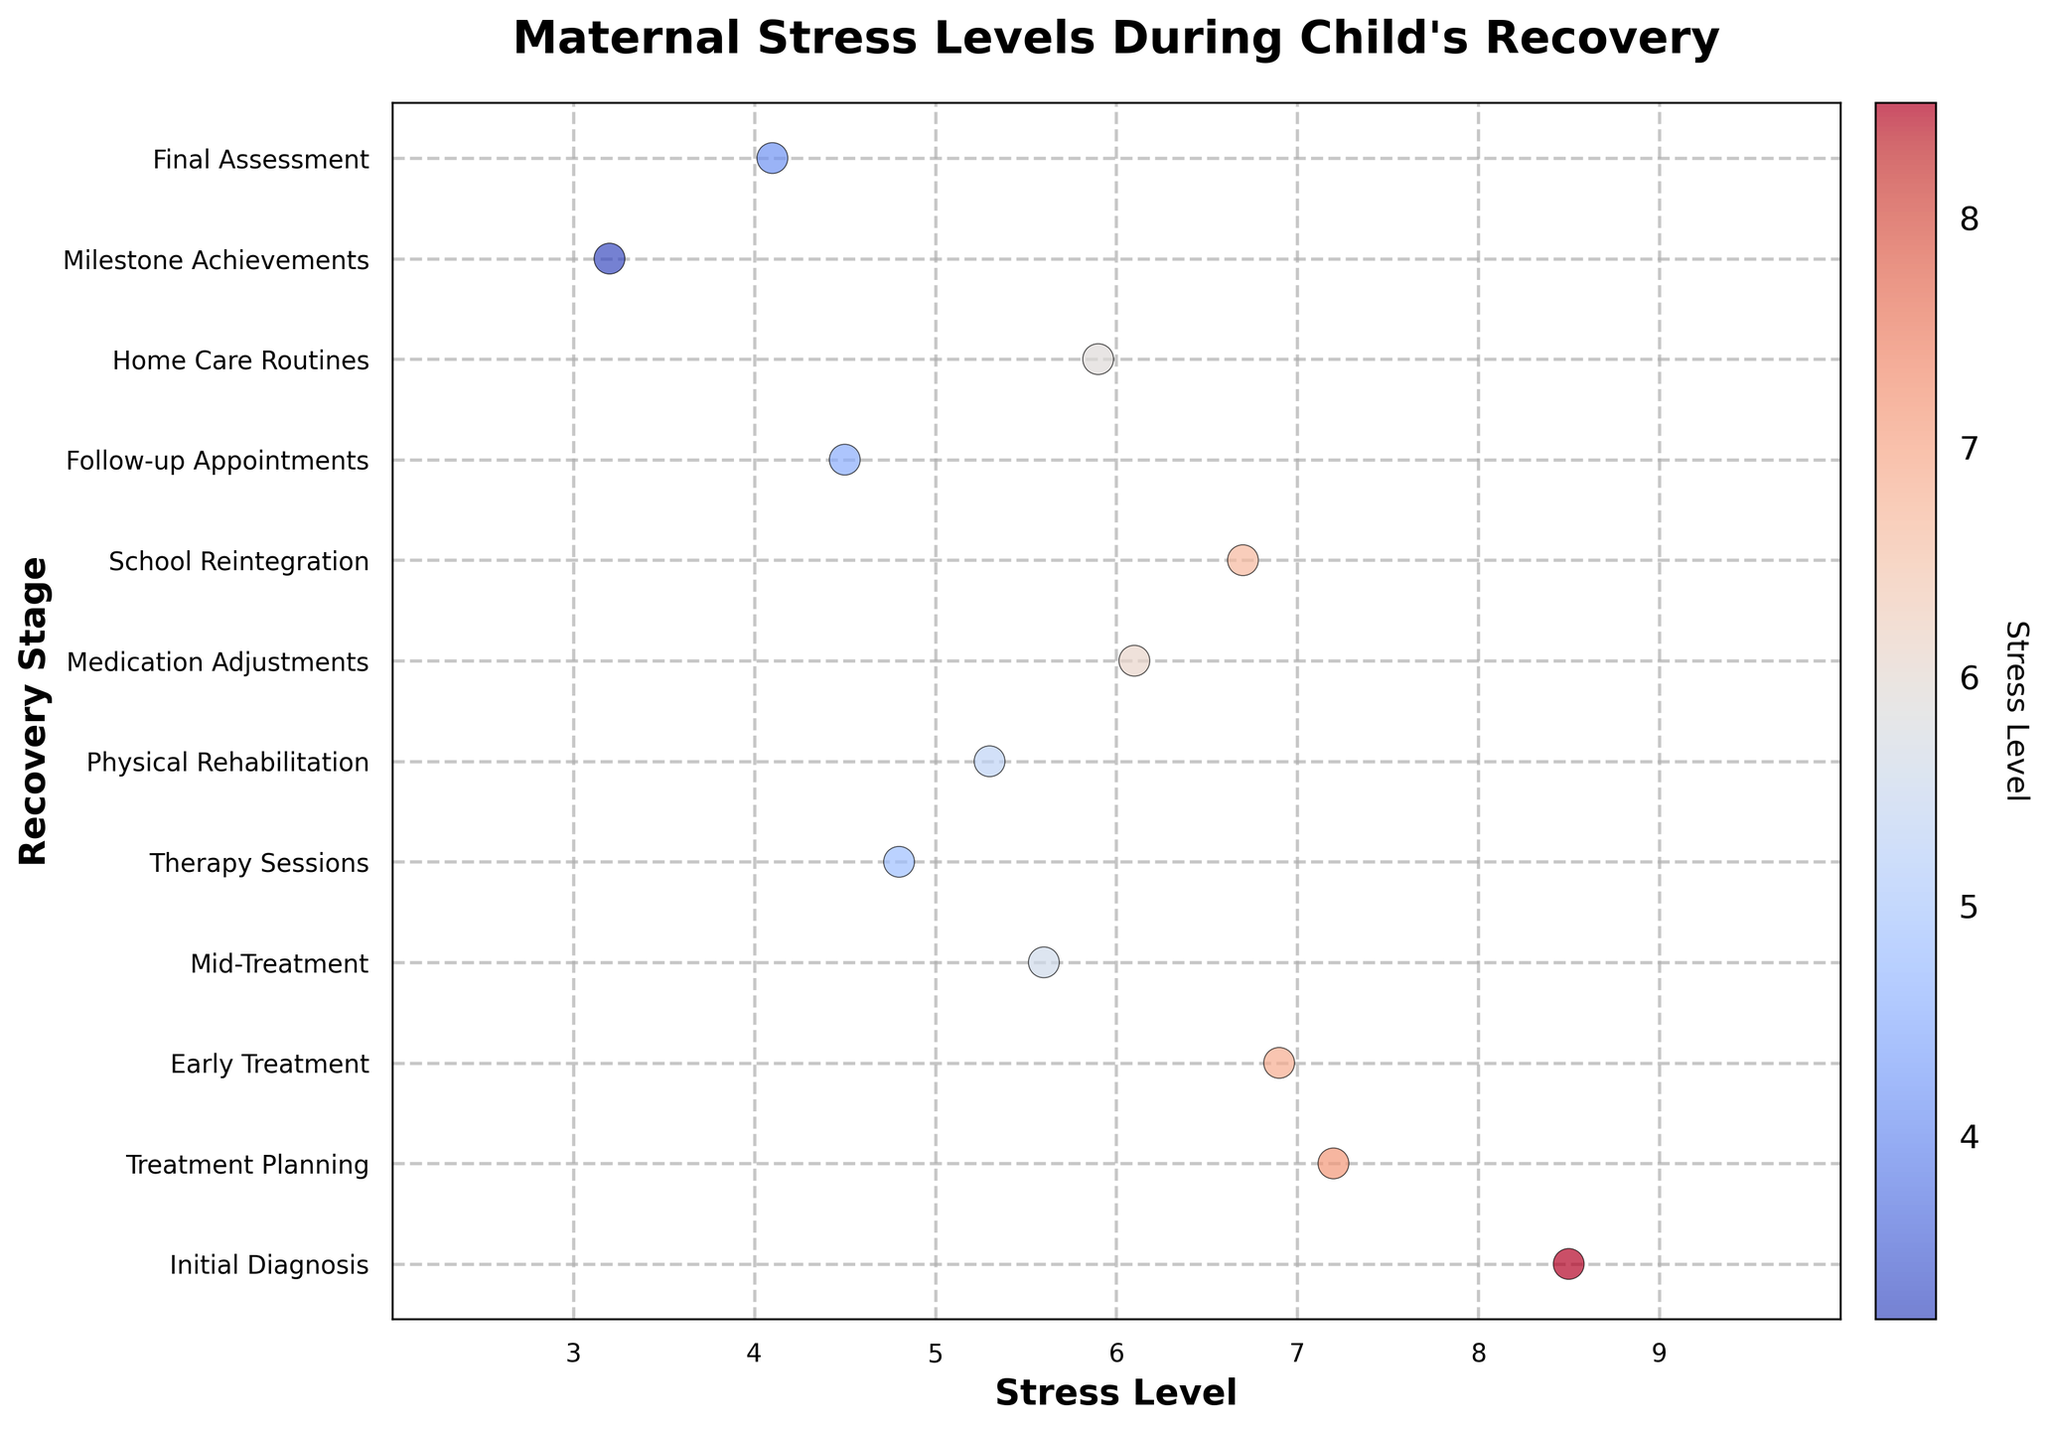What is the title of the plot? The title of the plot is displayed at the top. The text is bold and larger in size compared to the other text elements in the plot.
Answer: Maternal Stress Levels During Child's Recovery What is the stress level at the stage "Mid-Treatment"? Locate the point on the plot corresponding to "Mid-Treatment" on the y-axis, then trace horizontally to find the stress level value on the x-axis.
Answer: 5.6 Which recovery stage has the lowest stress level? Look for the point with the lowest value on the x-axis. Check the corresponding stage on the y-axis labels.
Answer: Milestone Achievements How many stages have stress levels above 6? Count the number of points located to the right of the stress level value of 6 on the x-axis.
Answer: 5 Compare the stress levels between "Initial Diagnosis" and "Final Assessment". Which stage has a higher stress level? Locate both "Initial Diagnosis" and "Final Assessment" on the y-axis, then compare their respective stress levels on the x-axis.
Answer: Initial Diagnosis What is the average stress level for the stages shown in the plot? Add all the stress levels together and divide by the number of stages (12). (8.5 + 7.2 + 6.9 + 5.6 + 4.8 + 5.3 + 6.1 + 6.7 + 4.5 + 5.9 + 3.2 + 4.1) / 12 ≈ 5.675
Answer: 5.675 Identify the color associated with the highest stress level. The color represents the stress level, and the highest stress level will correspond to the most intense shade on the color bar.
Answer: A shade of warm red Compare the stress levels at "Therapy Sessions" and "School Reintegration". Which stage has a lower stress level? Locate both "Therapy Sessions" and "School Reintegration" on the y-axis, then compare their respective stress levels on the x-axis.
Answer: Therapy Sessions What is the range of maternal stress levels observed in this plot? Find the difference between the maximum and minimum stress level points on the x-axis. 8.5 - 3.2 = 5.3
Answer: 5.3 Which stages have a stress level close to 6? Locate the points that are closest to the value of 6 on the x-axis and note their corresponding recovery stages on the y-axis.
Answer: Early Treatment, Medication Adjustments, School Reintegration 